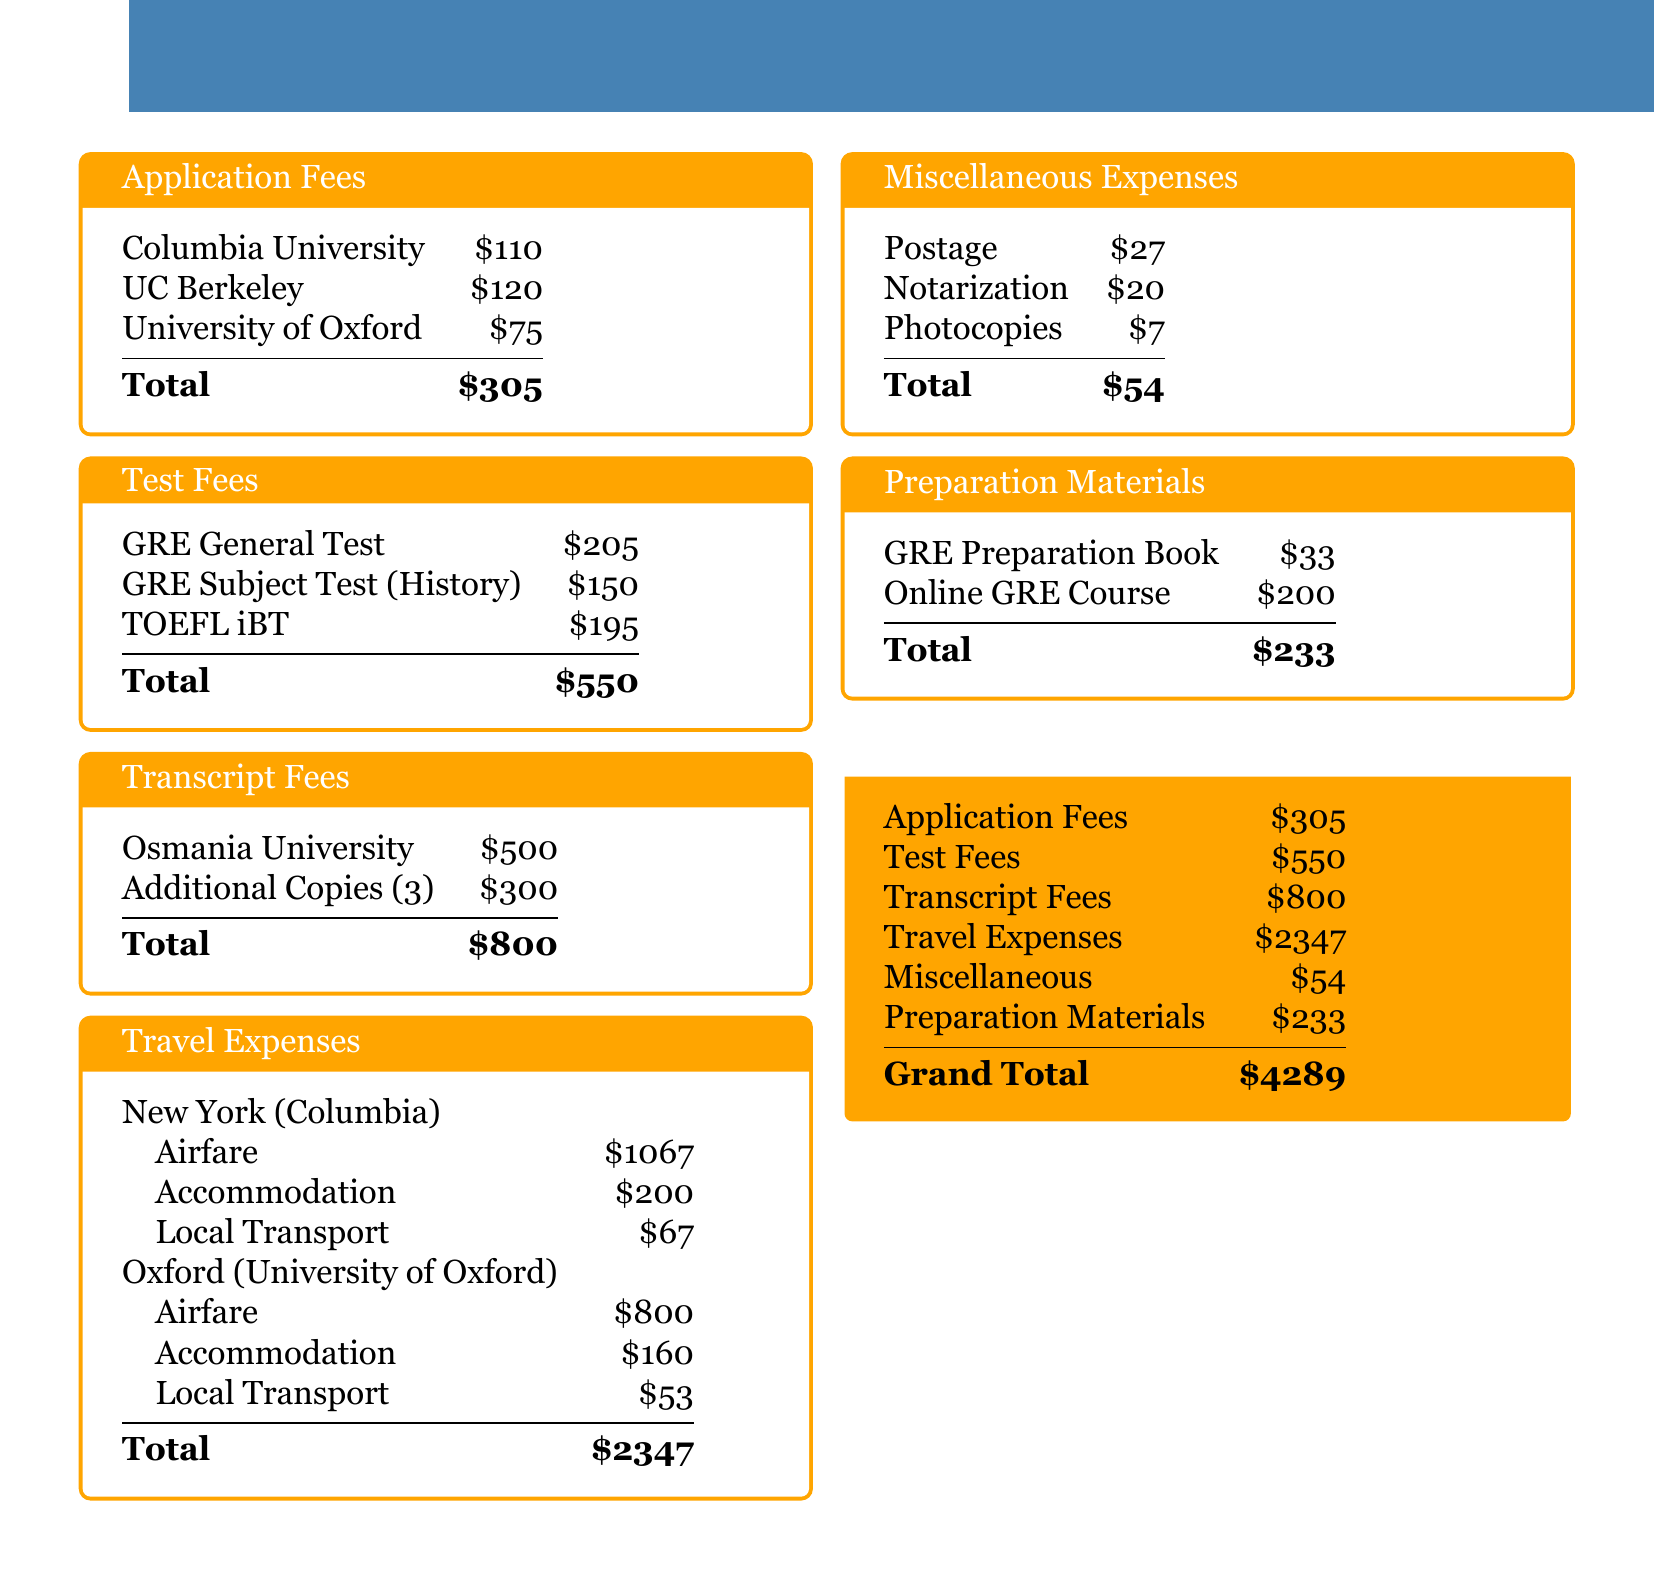How much is the application fee for Columbia University? The application fee for Columbia University is listed in the document under Application Fees.
Answer: $110 What is the total amount for test fees? The total amount for test fees is calculated by summing all the individual test fees listed in the document.
Answer: $550 How much did the airfare to New York cost? The airfare to New York for Columbia is specified in the Travel Expenses section.
Answer: $1067 What are the total miscellaneous expenses? The total miscellaneous expenses are the sum of all the listed miscellaneous items in the document.
Answer: $54 What is the total budget for the graduate school application process? The total budget is summarized in the Total Budget section as the grand total.
Answer: $4289 How much is the GRE Subject Test fee for History? The GRE Subject Test fee for History is specified in the Test Fees section.
Answer: $150 What is the cost of accommodation in Oxford? The cost of accommodation in Oxford is listed in the Travel Expenses section specifically for the University of Oxford.
Answer: $160 How many copies of transcripts were ordered? The document states that three additional copies of transcripts were ordered under Transcript Fees.
Answer: 3 What is the sum of application and transcript fees? The sum is calculated by adding the application fees and transcript fees together from the relevant sections.
Answer: $1105 